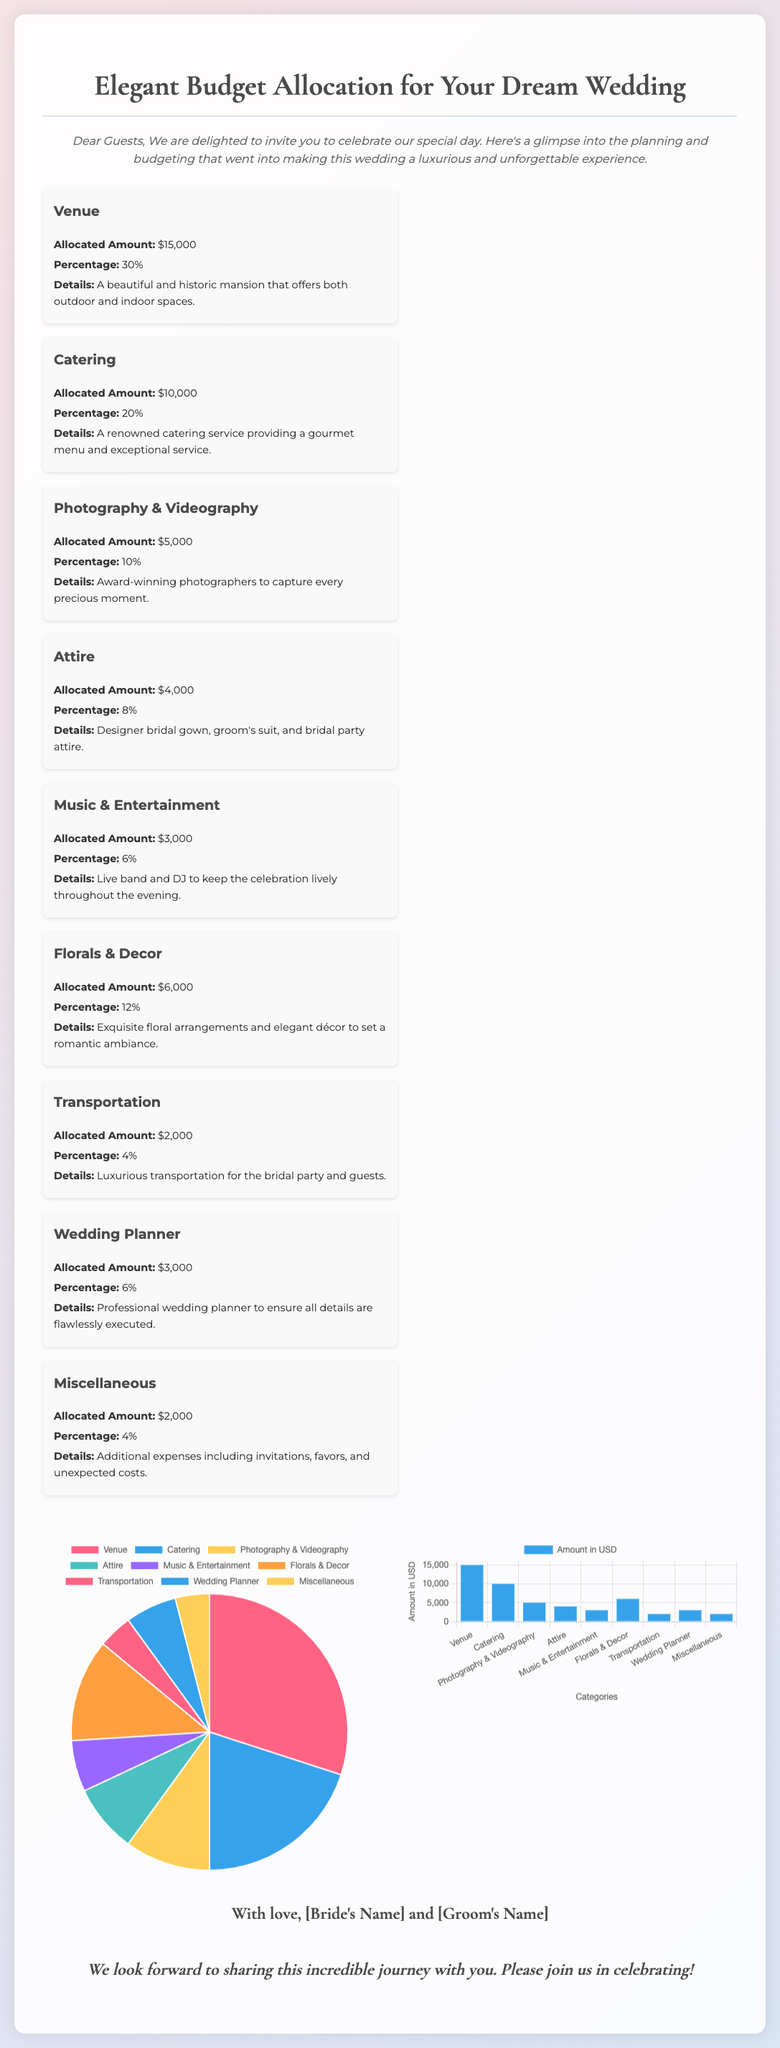What is the total allocated amount for the venue? The allocated amount for the venue is clearly stated in the document as $15,000.
Answer: $15,000 What percentage of the budget is allocated to catering? The document indicates that catering is allocated 20% of the total budget.
Answer: 20% How much is allocated for photography and videography? The budget details specifically state that photography and videography are allocated $5,000.
Answer: $5,000 Which category has the smallest allocated amount? By reviewing the allocated amounts, transportation has the smallest at $2,000.
Answer: Transportation How much do the florals and decor cost? The document provides that the cost for florals and decor is $6,000.
Answer: $6,000 Which category has a higher percentage, music and entertainment or attire? To reason this, we compare their percentages: music and entertainment is 6% and attire is 8%. Attire has a higher percentage.
Answer: Attire What does the document use to visually represent the budget allocation? The document uses charts, specifically a pie chart and a bar chart, to illustrate the budget allocation.
Answer: Charts Who are the names mentioned at the end of the invitation? The footer conveys that the names included are those of the bride and groom as placeholders: [Bride's Name] and [Groom's Name].
Answer: [Bride's Name] and [Groom's Name] What overall theme does the document convey for the wedding budget? The document indicates through its design and language that the wedding budget is planned with elegance and luxury in mind.
Answer: Elegant budget allocation 